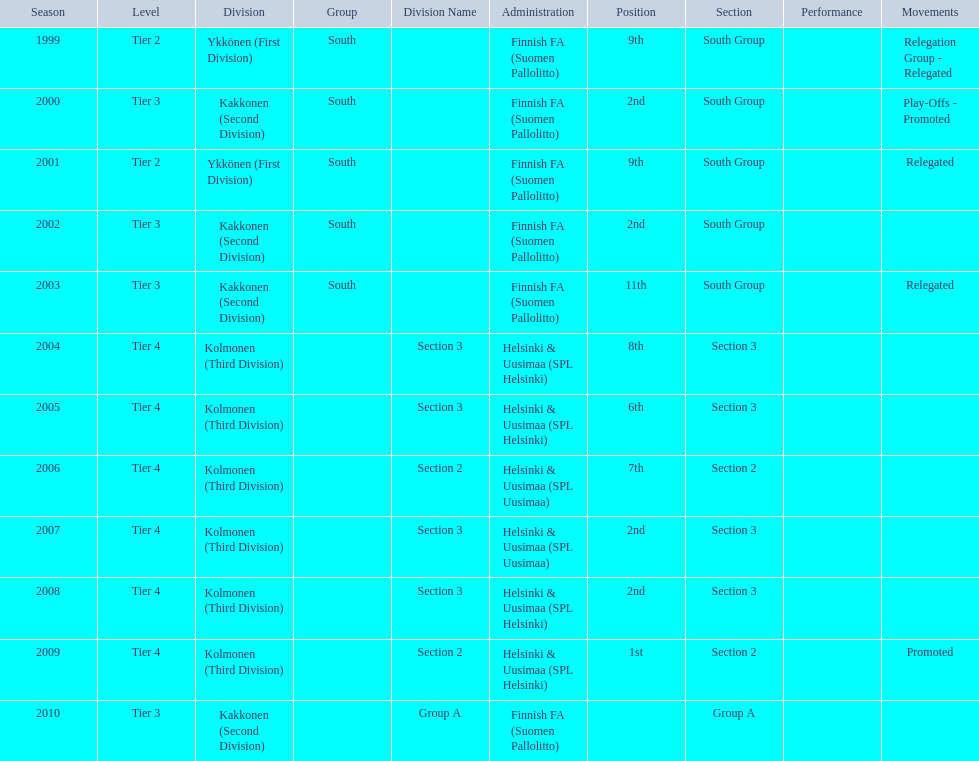What position did this team get after getting 9th place in 1999? 2nd. 